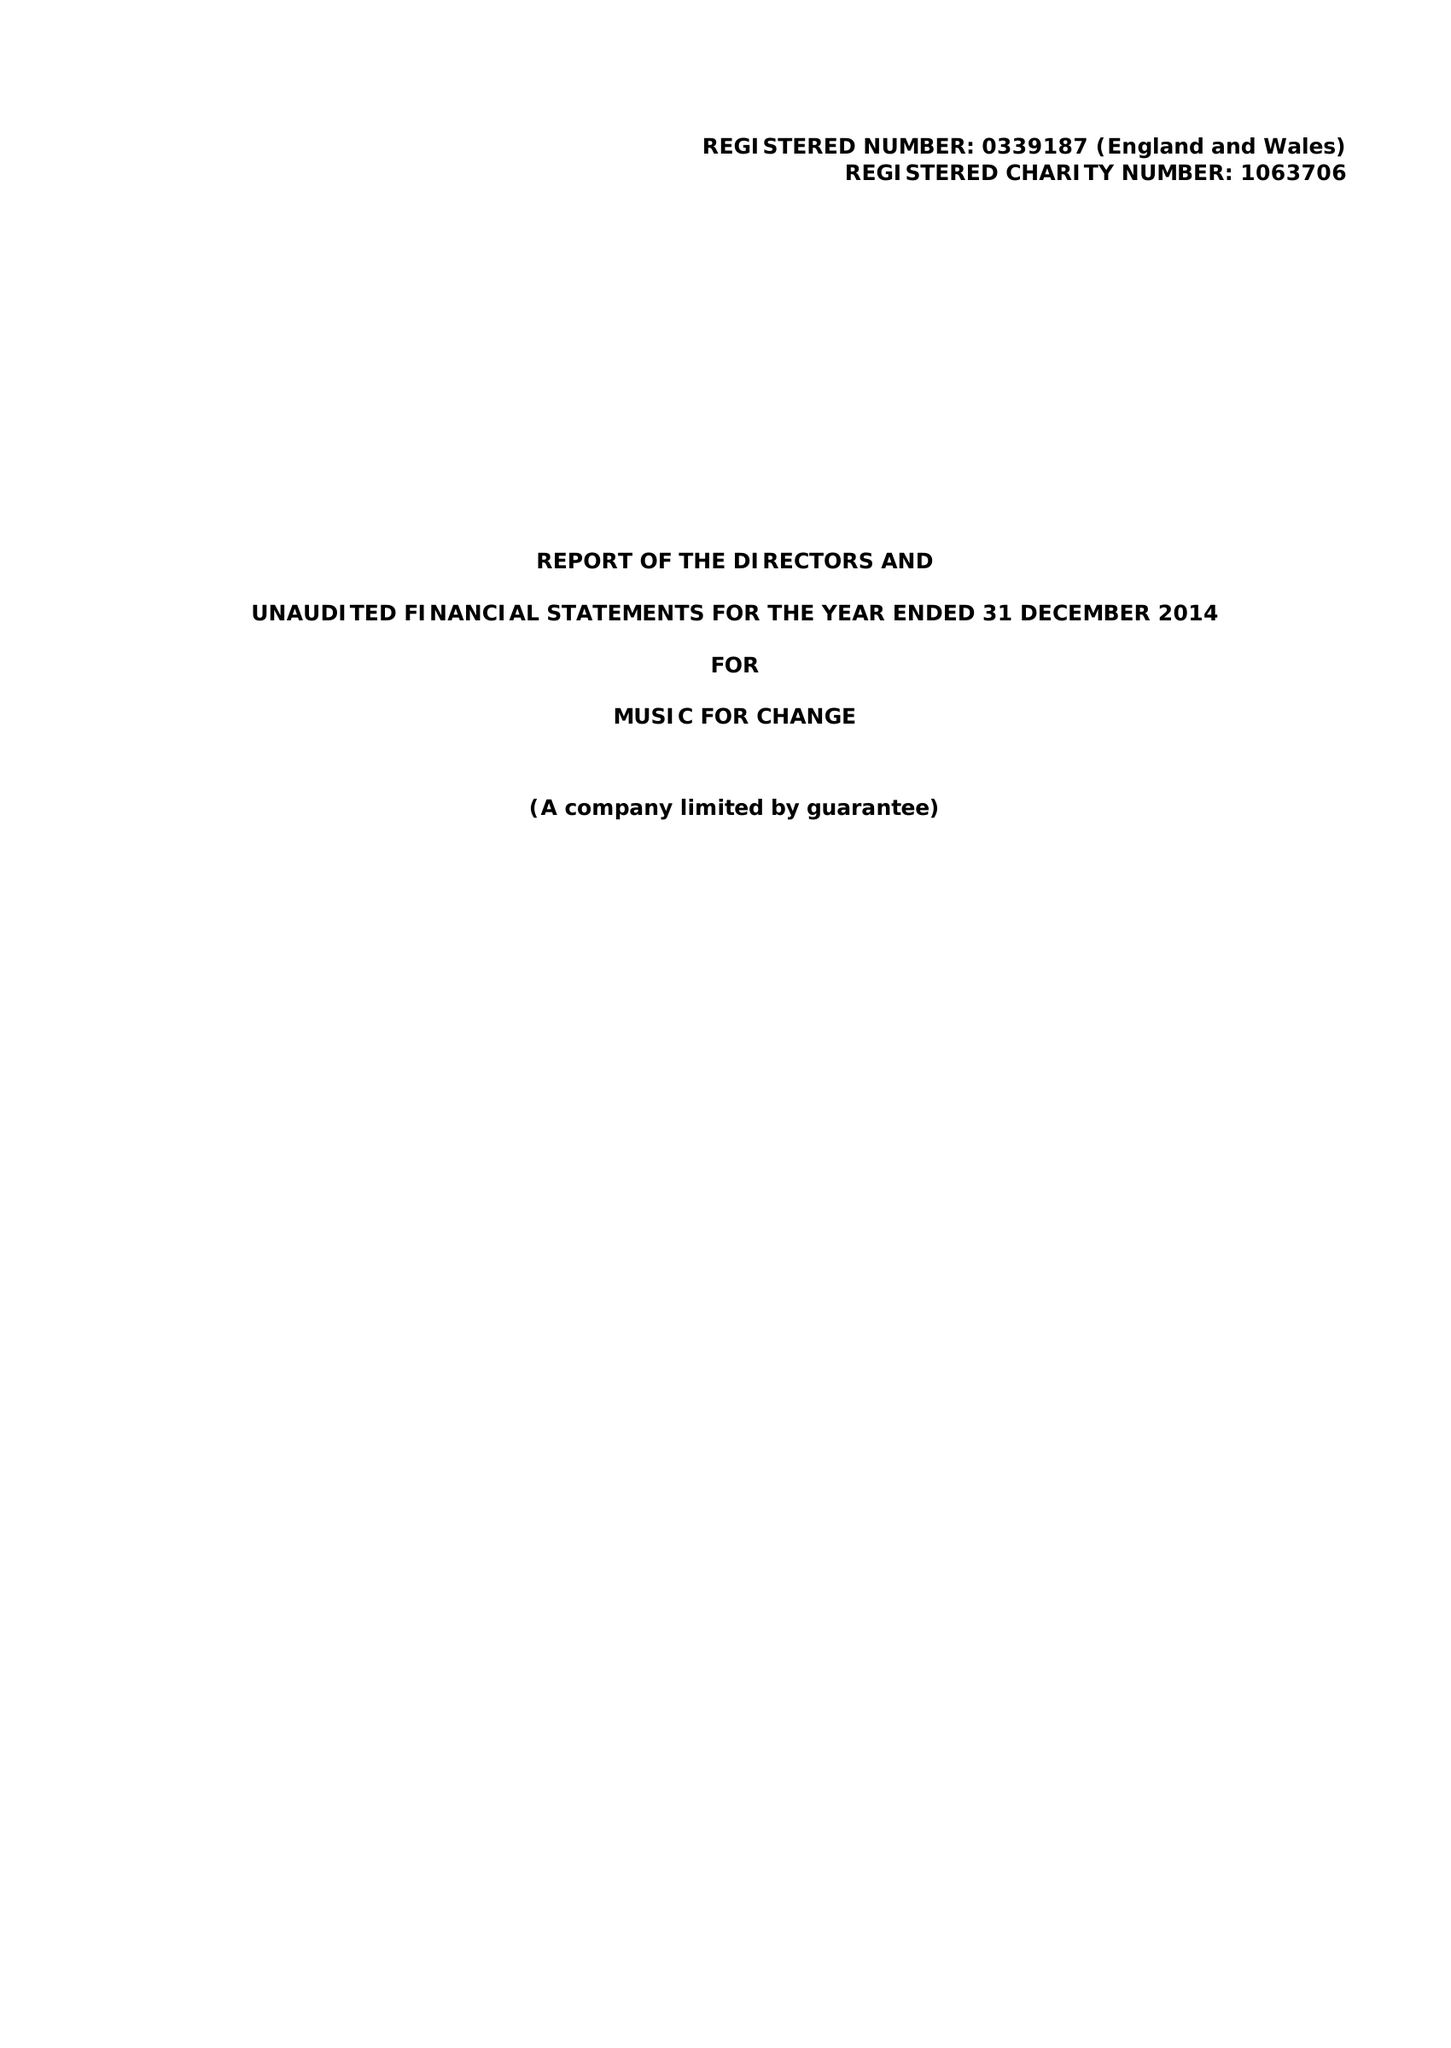What is the value for the report_date?
Answer the question using a single word or phrase. 2014-12-31 